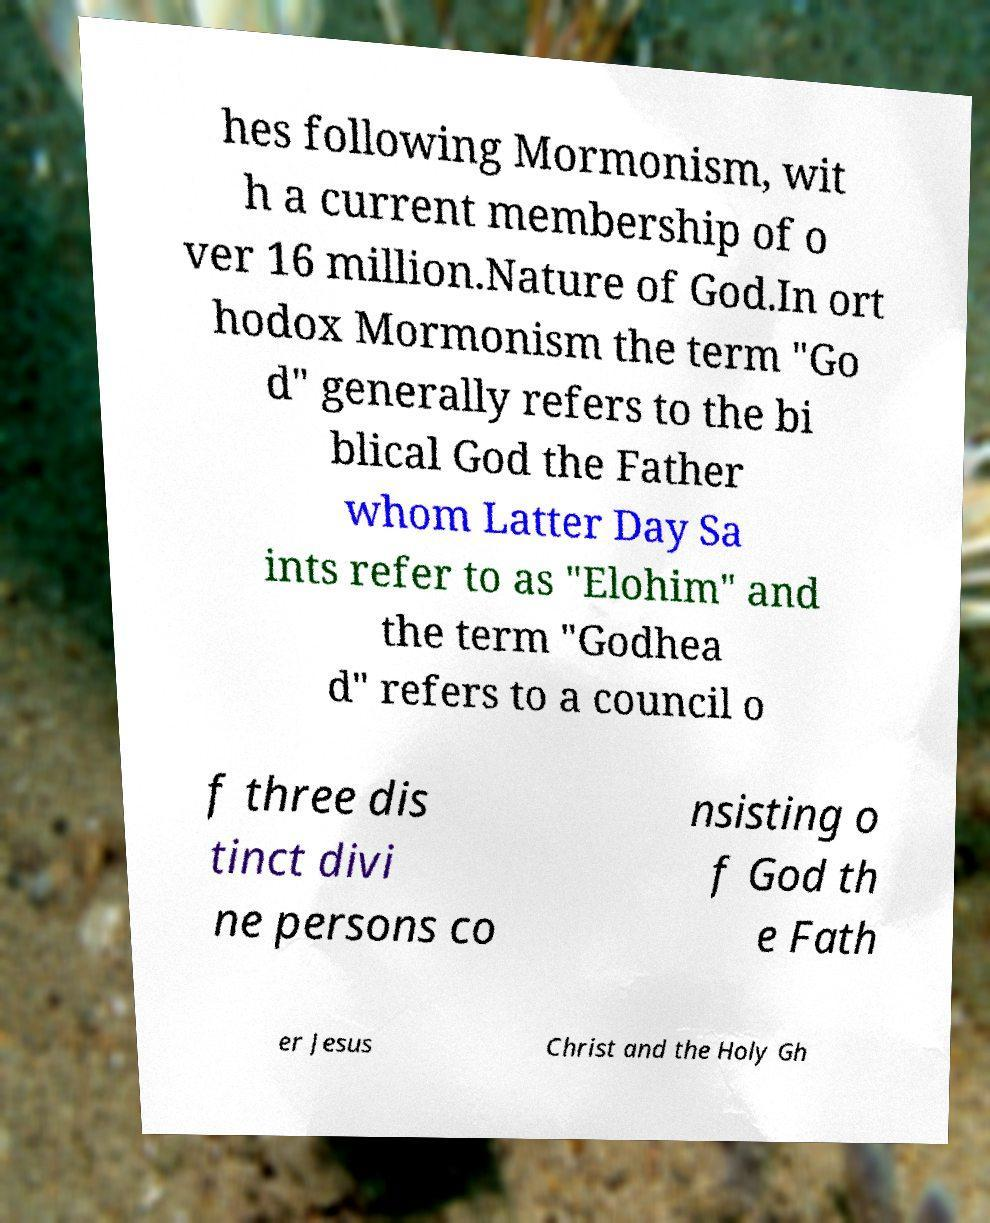Could you assist in decoding the text presented in this image and type it out clearly? hes following Mormonism, wit h a current membership of o ver 16 million.Nature of God.In ort hodox Mormonism the term "Go d" generally refers to the bi blical God the Father whom Latter Day Sa ints refer to as "Elohim" and the term "Godhea d" refers to a council o f three dis tinct divi ne persons co nsisting o f God th e Fath er Jesus Christ and the Holy Gh 